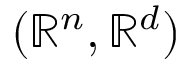<formula> <loc_0><loc_0><loc_500><loc_500>( \mathbb { R } ^ { n } , \mathbb { R } ^ { d } )</formula> 